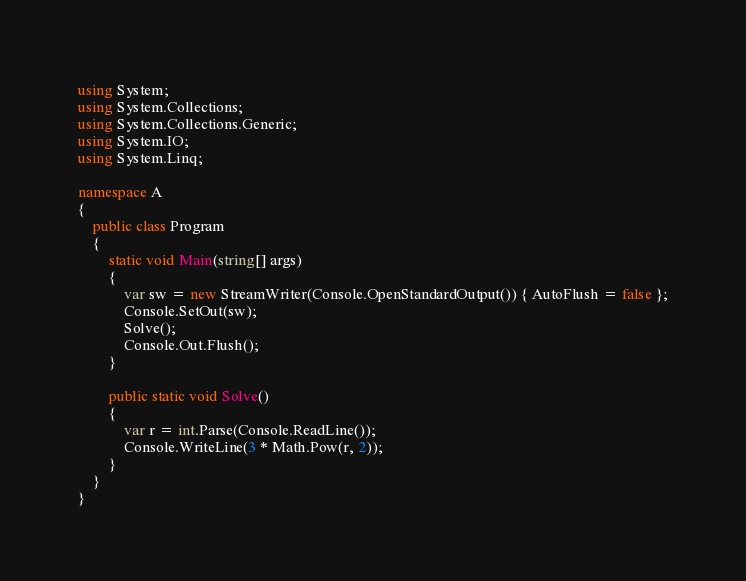Convert code to text. <code><loc_0><loc_0><loc_500><loc_500><_C#_>using System;
using System.Collections;
using System.Collections.Generic;
using System.IO;
using System.Linq;

namespace A
{
    public class Program
    {
        static void Main(string[] args)
        {
            var sw = new StreamWriter(Console.OpenStandardOutput()) { AutoFlush = false };
            Console.SetOut(sw);
            Solve();
            Console.Out.Flush();
        }

        public static void Solve()
        {
            var r = int.Parse(Console.ReadLine());
            Console.WriteLine(3 * Math.Pow(r, 2));
        }
    }
}
</code> 